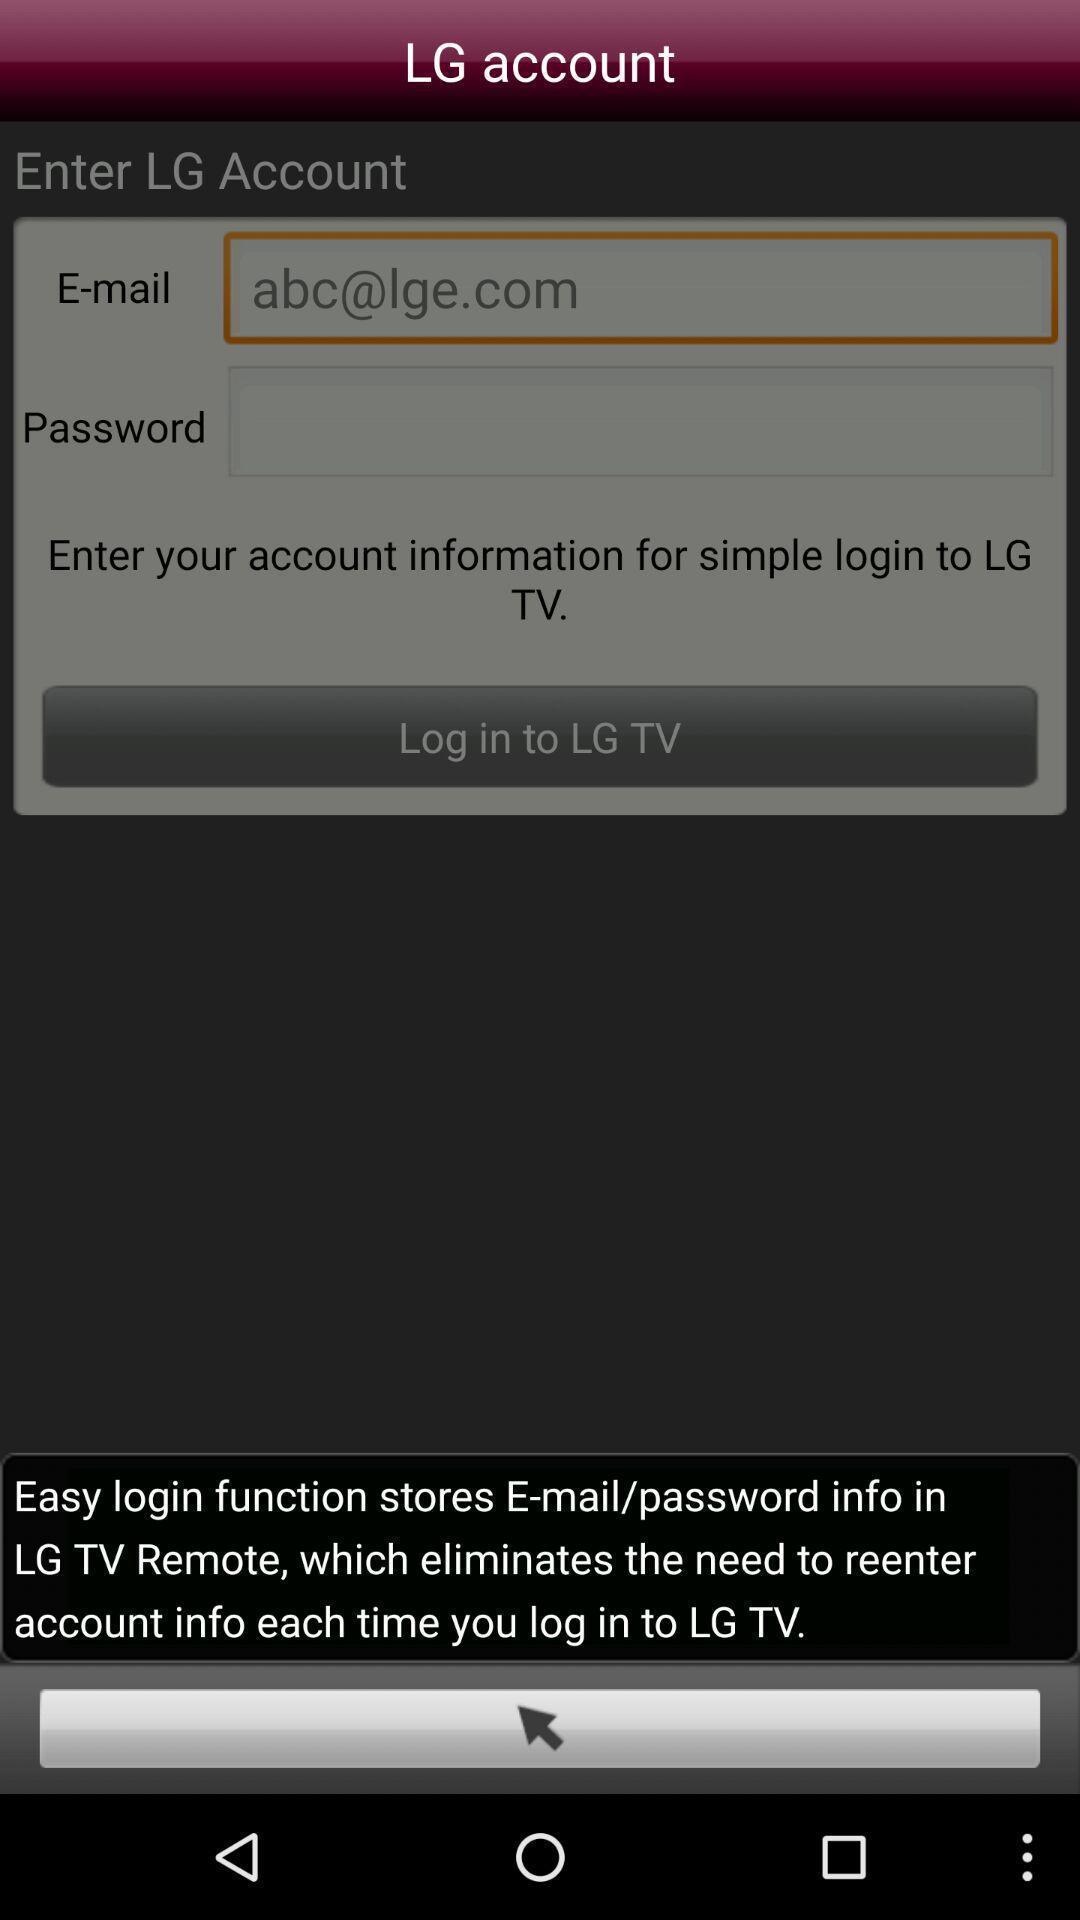Tell me what you see in this picture. Screen shows information about an account. 